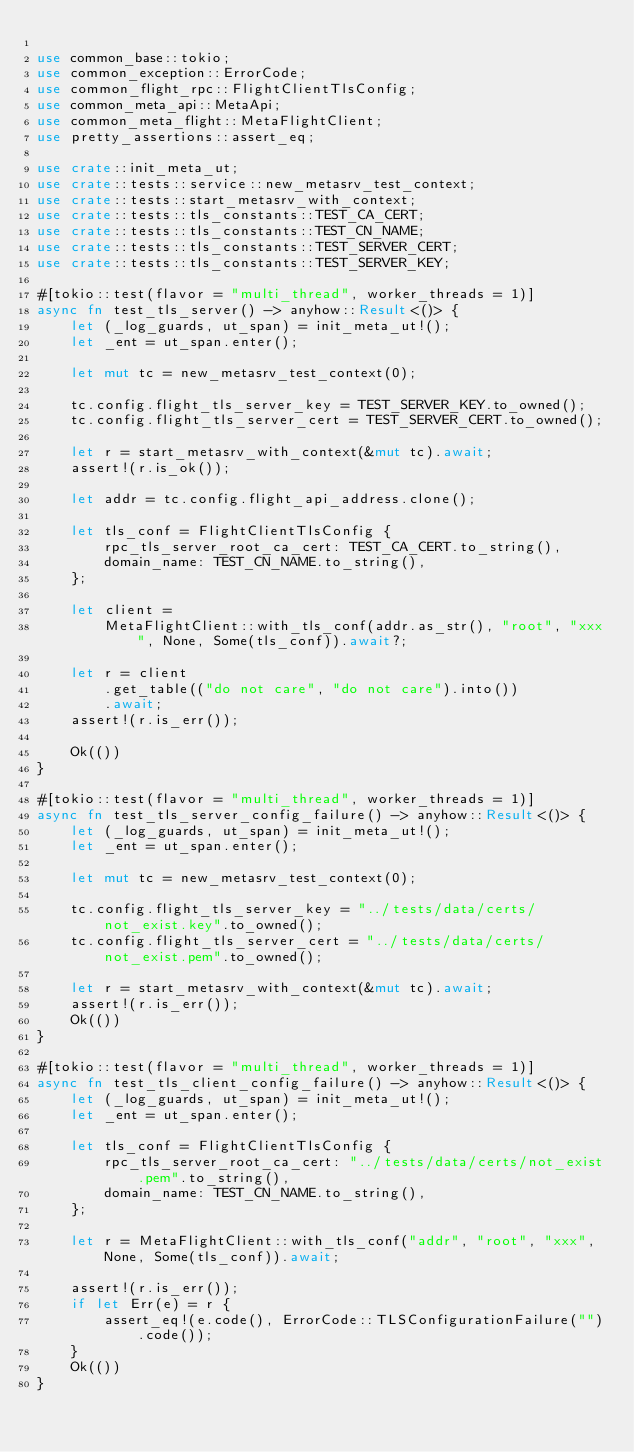Convert code to text. <code><loc_0><loc_0><loc_500><loc_500><_Rust_>
use common_base::tokio;
use common_exception::ErrorCode;
use common_flight_rpc::FlightClientTlsConfig;
use common_meta_api::MetaApi;
use common_meta_flight::MetaFlightClient;
use pretty_assertions::assert_eq;

use crate::init_meta_ut;
use crate::tests::service::new_metasrv_test_context;
use crate::tests::start_metasrv_with_context;
use crate::tests::tls_constants::TEST_CA_CERT;
use crate::tests::tls_constants::TEST_CN_NAME;
use crate::tests::tls_constants::TEST_SERVER_CERT;
use crate::tests::tls_constants::TEST_SERVER_KEY;

#[tokio::test(flavor = "multi_thread", worker_threads = 1)]
async fn test_tls_server() -> anyhow::Result<()> {
    let (_log_guards, ut_span) = init_meta_ut!();
    let _ent = ut_span.enter();

    let mut tc = new_metasrv_test_context(0);

    tc.config.flight_tls_server_key = TEST_SERVER_KEY.to_owned();
    tc.config.flight_tls_server_cert = TEST_SERVER_CERT.to_owned();

    let r = start_metasrv_with_context(&mut tc).await;
    assert!(r.is_ok());

    let addr = tc.config.flight_api_address.clone();

    let tls_conf = FlightClientTlsConfig {
        rpc_tls_server_root_ca_cert: TEST_CA_CERT.to_string(),
        domain_name: TEST_CN_NAME.to_string(),
    };

    let client =
        MetaFlightClient::with_tls_conf(addr.as_str(), "root", "xxx", None, Some(tls_conf)).await?;

    let r = client
        .get_table(("do not care", "do not care").into())
        .await;
    assert!(r.is_err());

    Ok(())
}

#[tokio::test(flavor = "multi_thread", worker_threads = 1)]
async fn test_tls_server_config_failure() -> anyhow::Result<()> {
    let (_log_guards, ut_span) = init_meta_ut!();
    let _ent = ut_span.enter();

    let mut tc = new_metasrv_test_context(0);

    tc.config.flight_tls_server_key = "../tests/data/certs/not_exist.key".to_owned();
    tc.config.flight_tls_server_cert = "../tests/data/certs/not_exist.pem".to_owned();

    let r = start_metasrv_with_context(&mut tc).await;
    assert!(r.is_err());
    Ok(())
}

#[tokio::test(flavor = "multi_thread", worker_threads = 1)]
async fn test_tls_client_config_failure() -> anyhow::Result<()> {
    let (_log_guards, ut_span) = init_meta_ut!();
    let _ent = ut_span.enter();

    let tls_conf = FlightClientTlsConfig {
        rpc_tls_server_root_ca_cert: "../tests/data/certs/not_exist.pem".to_string(),
        domain_name: TEST_CN_NAME.to_string(),
    };

    let r = MetaFlightClient::with_tls_conf("addr", "root", "xxx", None, Some(tls_conf)).await;

    assert!(r.is_err());
    if let Err(e) = r {
        assert_eq!(e.code(), ErrorCode::TLSConfigurationFailure("").code());
    }
    Ok(())
}
</code> 